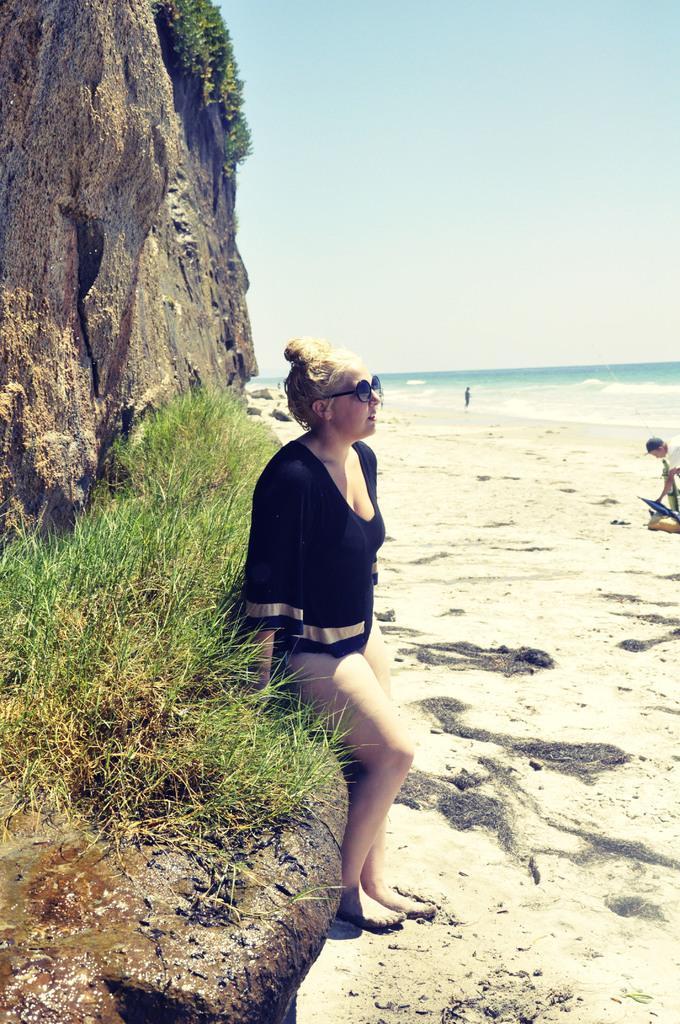Please provide a concise description of this image. In the center of the image we can see a lady standing. On the left there is a rock. There is grass. In the background there are people and sky. At the bottom there is sand. On the right there is water. 